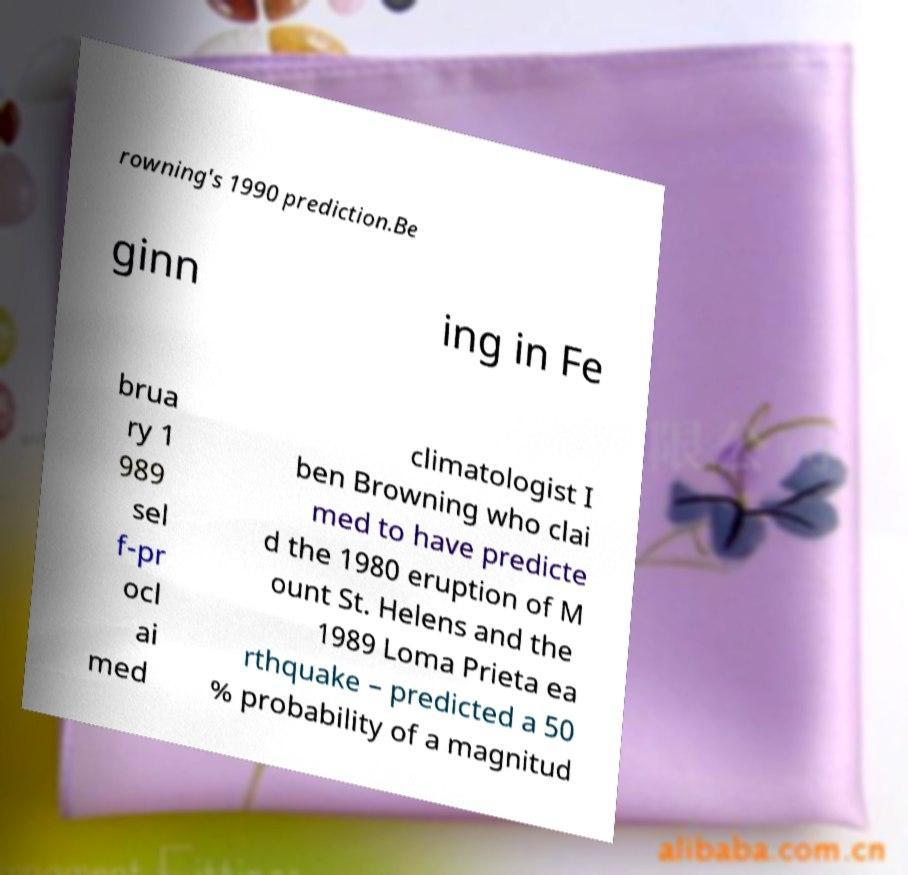Can you read and provide the text displayed in the image?This photo seems to have some interesting text. Can you extract and type it out for me? rowning's 1990 prediction.Be ginn ing in Fe brua ry 1 989 sel f-pr ocl ai med climatologist I ben Browning who clai med to have predicte d the 1980 eruption of M ount St. Helens and the 1989 Loma Prieta ea rthquake – predicted a 50 % probability of a magnitud 